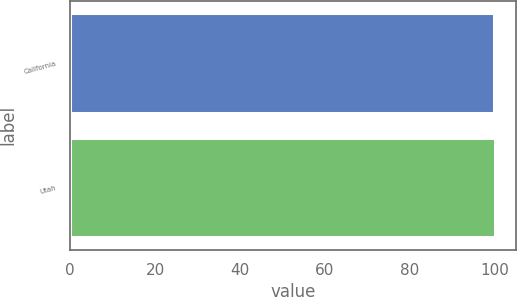Convert chart to OTSL. <chart><loc_0><loc_0><loc_500><loc_500><bar_chart><fcel>California<fcel>Utah<nl><fcel>100<fcel>100.1<nl></chart> 